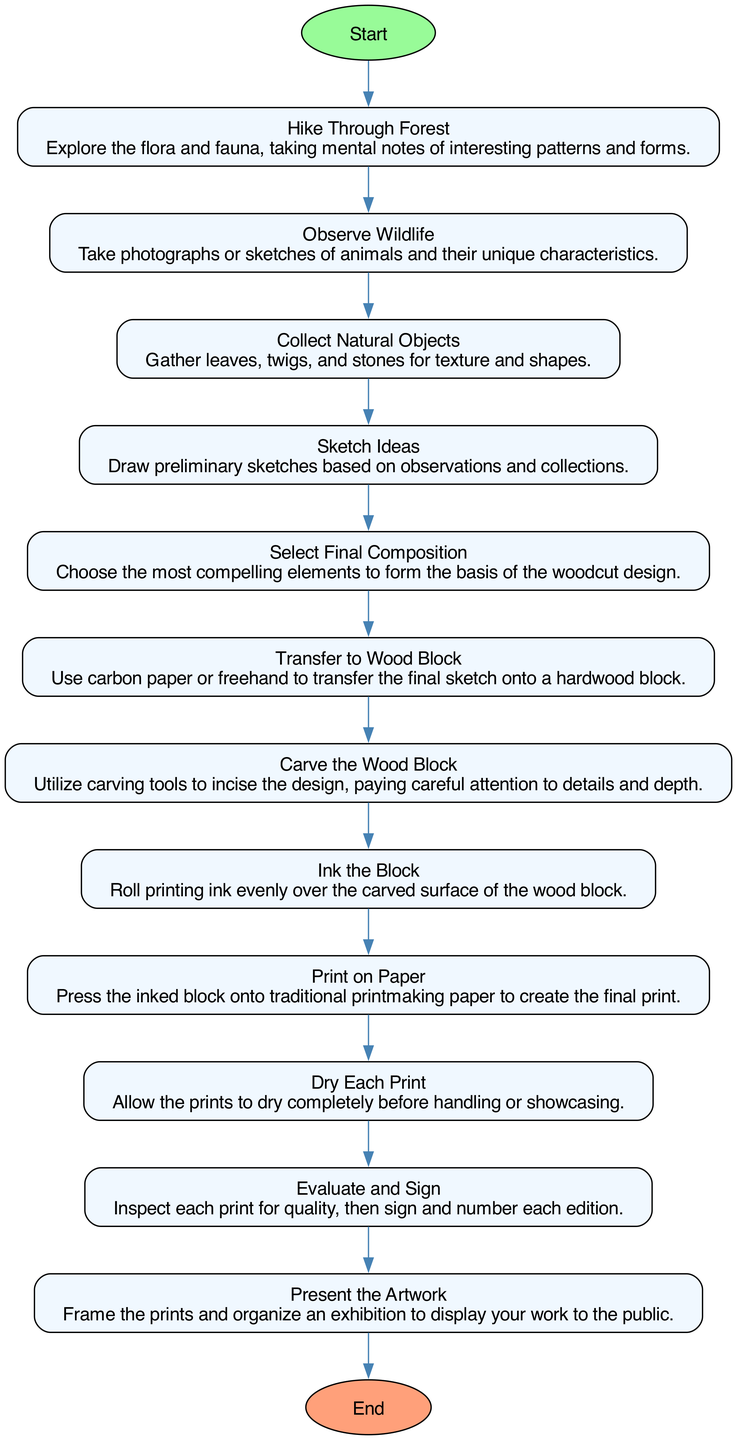What is the starting point of the process? The starting point of the process is indicated by the "Start" node in the diagram, which is labeled "Get Inspired by Nature". This represents the initial action that leads to subsequent steps.
Answer: Get Inspired by Nature How many actions are involved in transforming natural scenes into woodcut prints? By counting each action listed in the diagram, there are a total of 12 actions from "Hike Through Forest" to "Present the Artwork".
Answer: 12 What action immediately follows "Sketch Ideas"? By observing the flow of the diagram, the action that comes directly after "Sketch Ideas" is "Select Final Composition". This indicates the sequential nature of the creative process.
Answer: Select Final Composition Which action is the last before the exhibition opening? The last action prior to reaching the "End" node is "Present the Artwork". This action leads directly to the conclusion of the process, marking the culmination of the printmaking journey.
Answer: Present the Artwork How does "Ink the Block" relate to the previous action? The action "Ink the Block" follows "Carve the Wood Block" in the sequence. This relationship indicates that inking is a necessary step that occurs after carving the design into the wood.
Answer: Inking is after carving What is the relationship between "Collect Natural Objects" and "Observe Wildlife"? "Collect Natural Objects" and "Observe Wildlife" are both actions that can occur parallel during the inspiration phase before moving on to sketching. They are distinct actions, but both contribute to the initial creative process.
Answer: Parallel inspirations Which two actions are required before printing on paper? Reviewing the sequence, the two actions preceding "Print on Paper" are "Ink the Block" followed by "Carve the Wood Block". Both actions are prerequisites that must be completed to arrive at the printing stage.
Answer: Ink the Block and Carve the Wood Block How does the final artwork get evaluated? The final artwork is evaluated in the action "Evaluate and Sign", where each print is inspected for quality, and signatures are added to denote the edition of the prints. This step is essential before showcasing the work.
Answer: Evaluate and Sign What is the end stage of the transformation process? The endpoint of the transformation process is represented by the "End" node, which is labeled "Exhibition Opening", indicating the culmination of creating woodcut prints, leading to their public display.
Answer: Exhibition Opening 